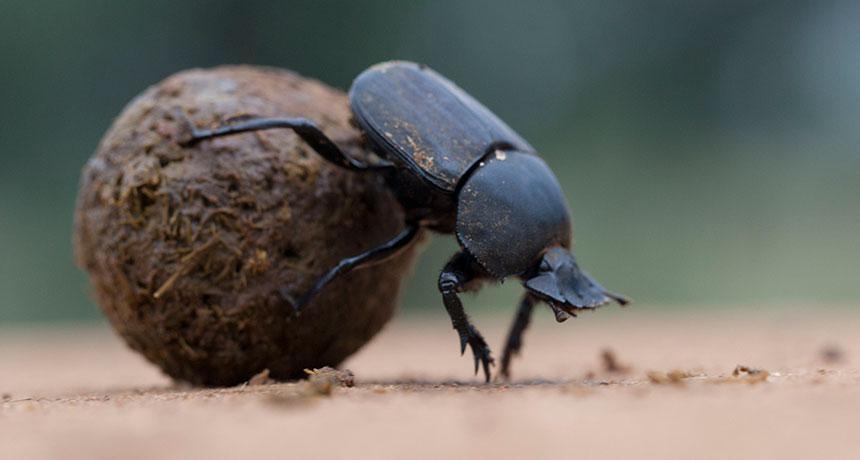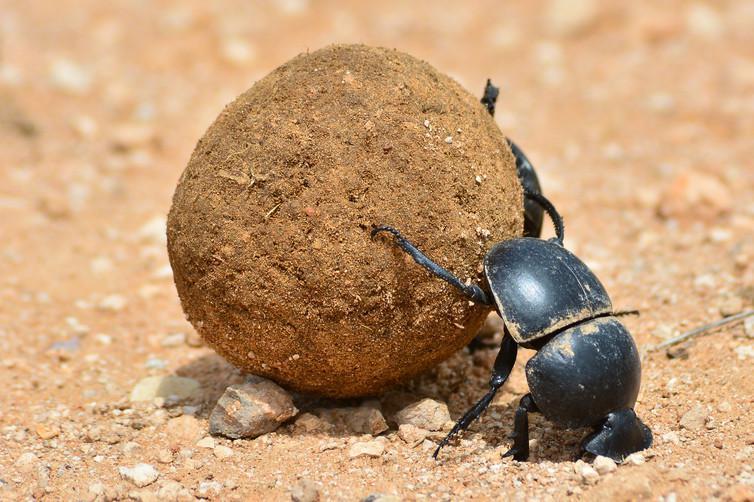The first image is the image on the left, the second image is the image on the right. Examine the images to the left and right. Is the description "One image has more than 20 dung beetles." accurate? Answer yes or no. No. The first image is the image on the left, the second image is the image on the right. Evaluate the accuracy of this statement regarding the images: "There are two dung beetles working on one ball of dung in natural lighting.". Is it true? Answer yes or no. No. 